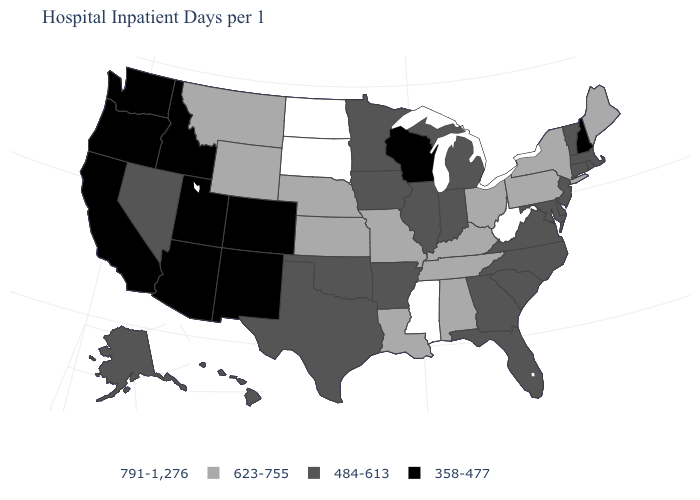Does Louisiana have a higher value than Hawaii?
Answer briefly. Yes. Name the states that have a value in the range 791-1,276?
Write a very short answer. Mississippi, North Dakota, South Dakota, West Virginia. Which states have the highest value in the USA?
Write a very short answer. Mississippi, North Dakota, South Dakota, West Virginia. Name the states that have a value in the range 484-613?
Short answer required. Alaska, Arkansas, Connecticut, Delaware, Florida, Georgia, Hawaii, Illinois, Indiana, Iowa, Maryland, Massachusetts, Michigan, Minnesota, Nevada, New Jersey, North Carolina, Oklahoma, Rhode Island, South Carolina, Texas, Vermont, Virginia. Name the states that have a value in the range 623-755?
Keep it brief. Alabama, Kansas, Kentucky, Louisiana, Maine, Missouri, Montana, Nebraska, New York, Ohio, Pennsylvania, Tennessee, Wyoming. What is the lowest value in states that border Georgia?
Keep it brief. 484-613. What is the value of Kentucky?
Keep it brief. 623-755. What is the highest value in states that border Minnesota?
Answer briefly. 791-1,276. Name the states that have a value in the range 484-613?
Quick response, please. Alaska, Arkansas, Connecticut, Delaware, Florida, Georgia, Hawaii, Illinois, Indiana, Iowa, Maryland, Massachusetts, Michigan, Minnesota, Nevada, New Jersey, North Carolina, Oklahoma, Rhode Island, South Carolina, Texas, Vermont, Virginia. What is the lowest value in states that border Tennessee?
Quick response, please. 484-613. Which states have the highest value in the USA?
Give a very brief answer. Mississippi, North Dakota, South Dakota, West Virginia. Does the map have missing data?
Answer briefly. No. Name the states that have a value in the range 484-613?
Answer briefly. Alaska, Arkansas, Connecticut, Delaware, Florida, Georgia, Hawaii, Illinois, Indiana, Iowa, Maryland, Massachusetts, Michigan, Minnesota, Nevada, New Jersey, North Carolina, Oklahoma, Rhode Island, South Carolina, Texas, Vermont, Virginia. What is the value of Utah?
Give a very brief answer. 358-477. What is the value of Nevada?
Concise answer only. 484-613. 